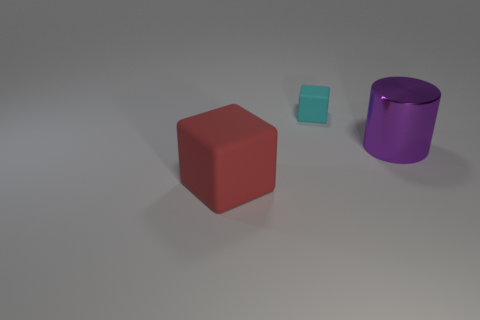Add 1 red matte objects. How many objects exist? 4 Subtract all cubes. How many objects are left? 1 Subtract all red things. Subtract all gray metal cylinders. How many objects are left? 2 Add 3 small matte things. How many small matte things are left? 4 Add 3 big red rubber objects. How many big red rubber objects exist? 4 Subtract 1 purple cylinders. How many objects are left? 2 